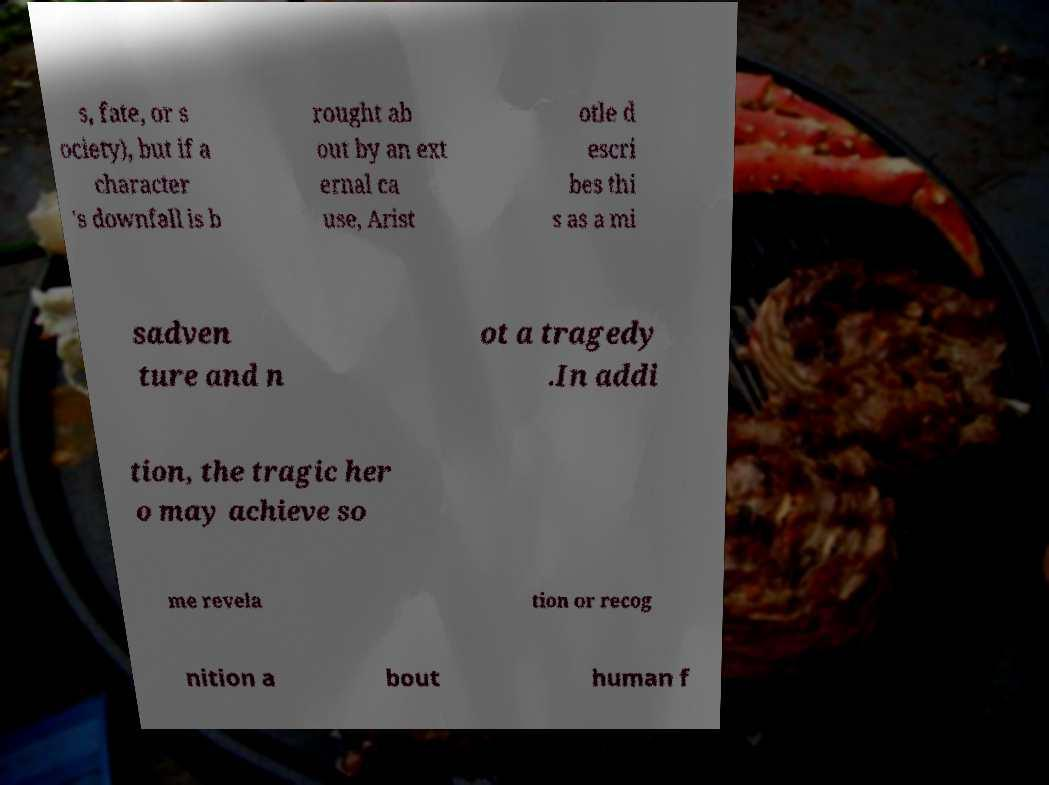I need the written content from this picture converted into text. Can you do that? s, fate, or s ociety), but if a character 's downfall is b rought ab out by an ext ernal ca use, Arist otle d escri bes thi s as a mi sadven ture and n ot a tragedy .In addi tion, the tragic her o may achieve so me revela tion or recog nition a bout human f 